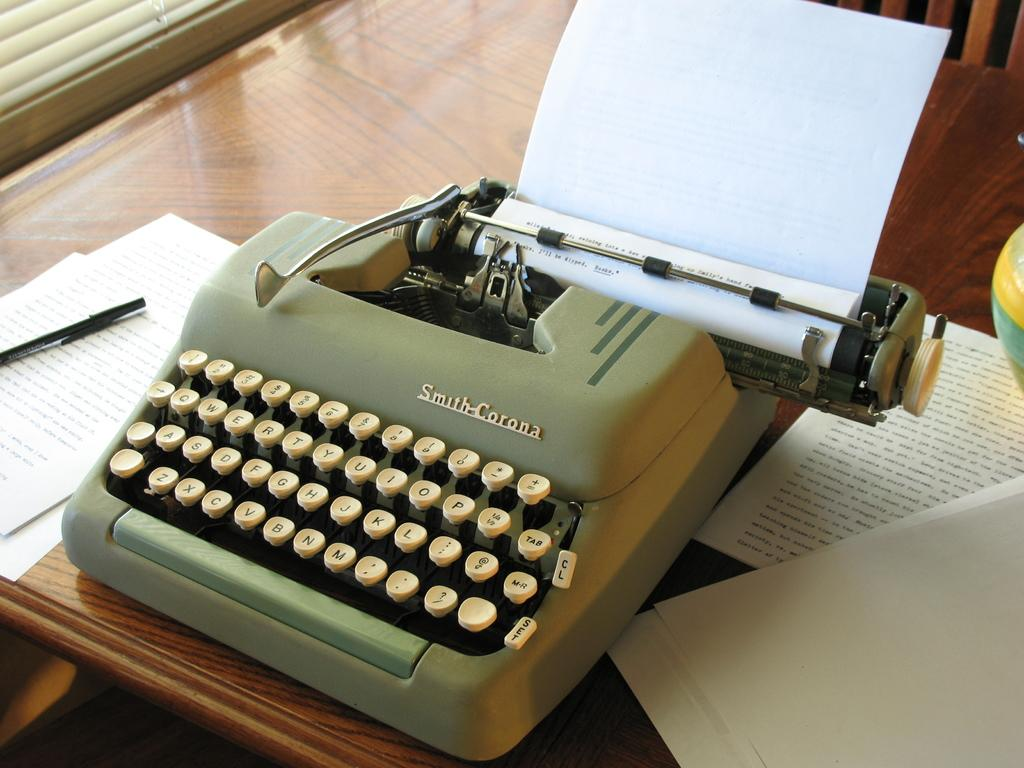Provide a one-sentence caption for the provided image. An old type writer from Smith-Corona company is on the table with paper rolled onto it. 